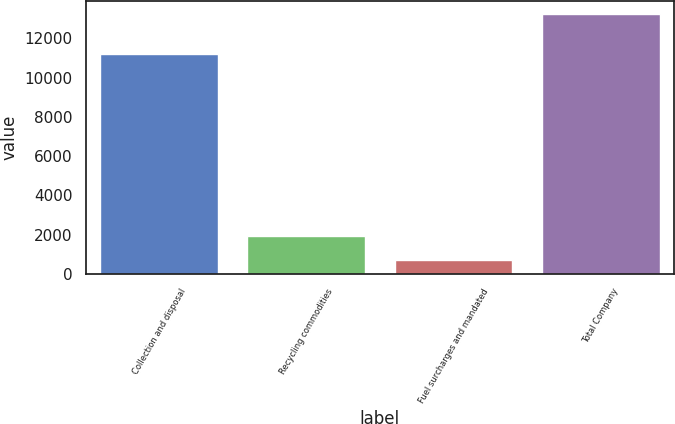Convert chart to OTSL. <chart><loc_0><loc_0><loc_500><loc_500><bar_chart><fcel>Collection and disposal<fcel>Recycling commodities<fcel>Fuel surcharges and mandated<fcel>Total Company<nl><fcel>11214<fcel>1943.5<fcel>689<fcel>13234<nl></chart> 